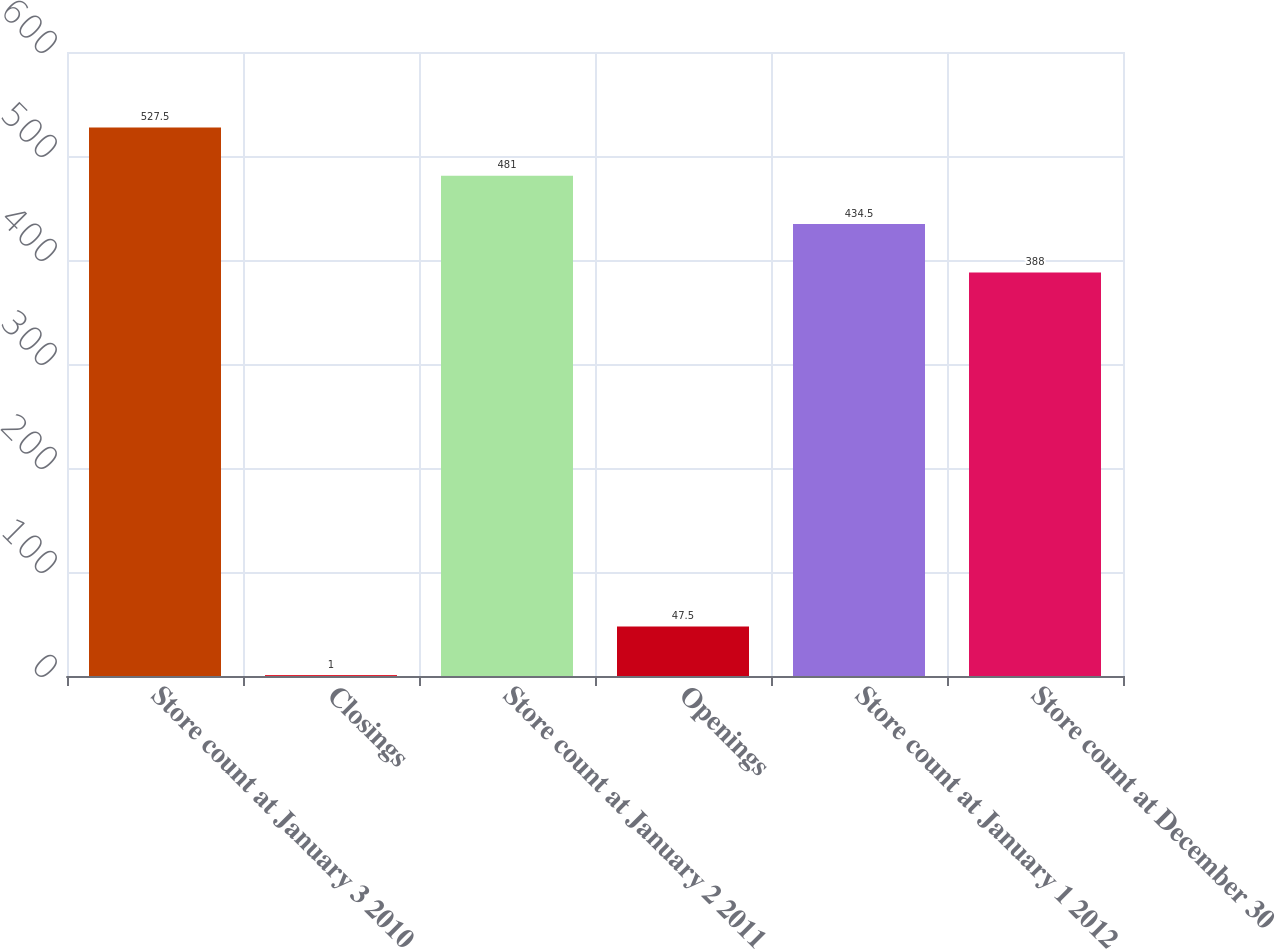<chart> <loc_0><loc_0><loc_500><loc_500><bar_chart><fcel>Store count at January 3 2010<fcel>Closings<fcel>Store count at January 2 2011<fcel>Openings<fcel>Store count at January 1 2012<fcel>Store count at December 30<nl><fcel>527.5<fcel>1<fcel>481<fcel>47.5<fcel>434.5<fcel>388<nl></chart> 